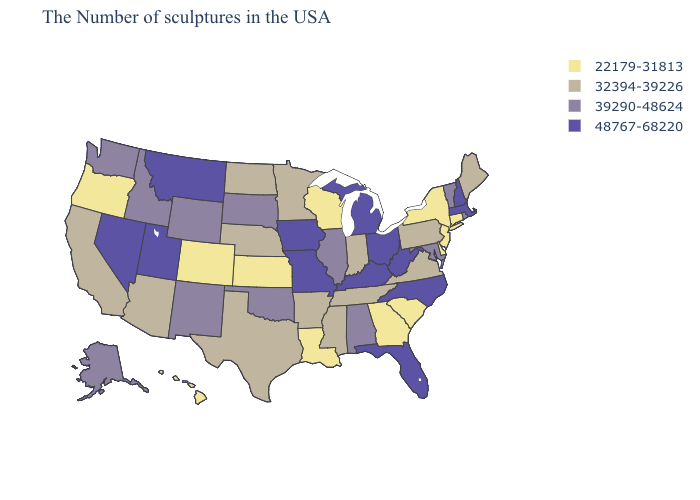Name the states that have a value in the range 39290-48624?
Be succinct. Rhode Island, Vermont, Maryland, Alabama, Illinois, Oklahoma, South Dakota, Wyoming, New Mexico, Idaho, Washington, Alaska. What is the value of Illinois?
Concise answer only. 39290-48624. Does Iowa have a higher value than Georgia?
Answer briefly. Yes. Does the map have missing data?
Give a very brief answer. No. Among the states that border Kansas , which have the highest value?
Write a very short answer. Missouri. Which states have the lowest value in the USA?
Be succinct. Connecticut, New York, New Jersey, Delaware, South Carolina, Georgia, Wisconsin, Louisiana, Kansas, Colorado, Oregon, Hawaii. Name the states that have a value in the range 39290-48624?
Give a very brief answer. Rhode Island, Vermont, Maryland, Alabama, Illinois, Oklahoma, South Dakota, Wyoming, New Mexico, Idaho, Washington, Alaska. What is the highest value in the USA?
Keep it brief. 48767-68220. Name the states that have a value in the range 32394-39226?
Answer briefly. Maine, Pennsylvania, Virginia, Indiana, Tennessee, Mississippi, Arkansas, Minnesota, Nebraska, Texas, North Dakota, Arizona, California. What is the lowest value in the USA?
Quick response, please. 22179-31813. Does the first symbol in the legend represent the smallest category?
Answer briefly. Yes. What is the lowest value in the USA?
Write a very short answer. 22179-31813. Does Maryland have the highest value in the USA?
Give a very brief answer. No. What is the value of Arkansas?
Short answer required. 32394-39226. What is the lowest value in the Northeast?
Give a very brief answer. 22179-31813. 